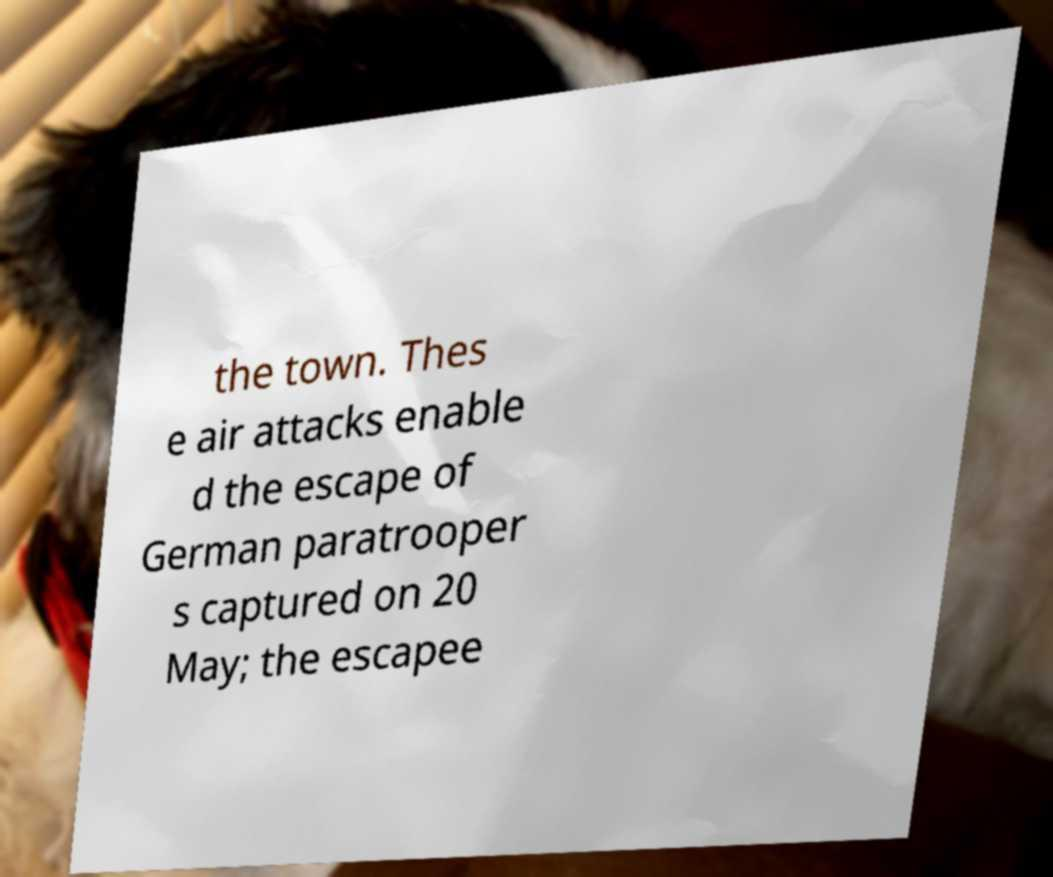Can you accurately transcribe the text from the provided image for me? the town. Thes e air attacks enable d the escape of German paratrooper s captured on 20 May; the escapee 